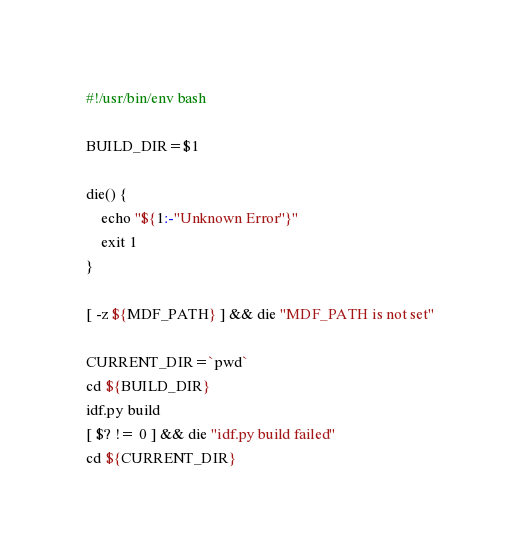<code> <loc_0><loc_0><loc_500><loc_500><_Bash_>#!/usr/bin/env bash

BUILD_DIR=$1

die() {
    echo "${1:-"Unknown Error"}"
    exit 1
}

[ -z ${MDF_PATH} ] && die "MDF_PATH is not set"

CURRENT_DIR=`pwd`
cd ${BUILD_DIR}
idf.py build
[ $? != 0 ] && die "idf.py build failed"
cd ${CURRENT_DIR}</code> 